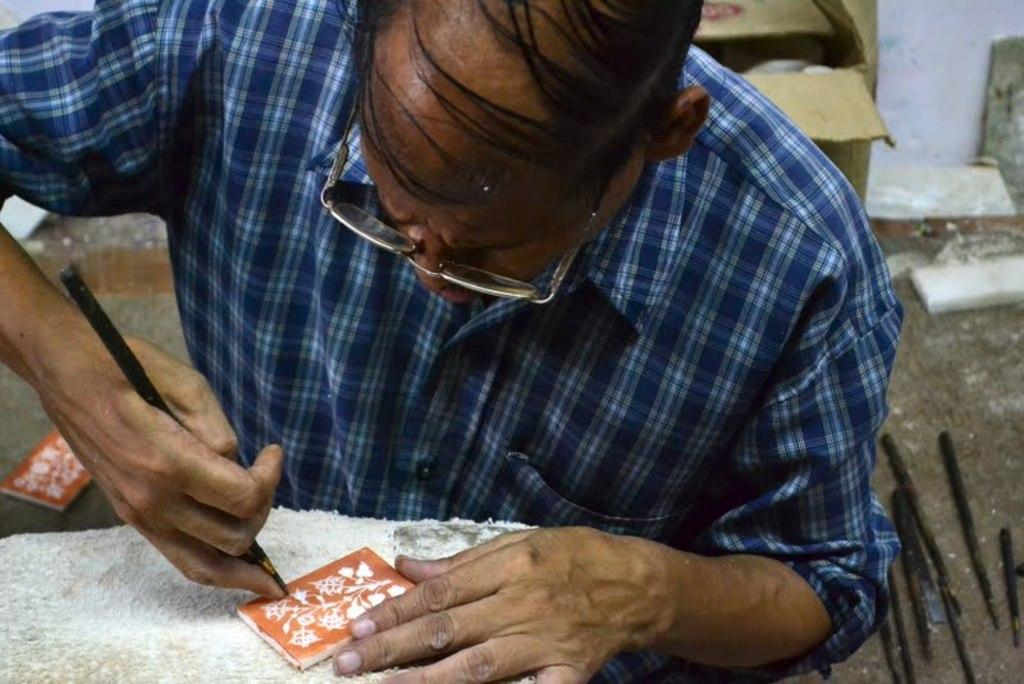What is the person in the image holding? There is a person holding an object in the image. What type of natural elements can be seen in the image? There are stones in the image. What type of material is present in the image? There is cloth in the image. What type of structure is visible in the image? There is a wall in the image. Can you describe any other objects in the image? There are other unspecified objects in the image. How does the nerve affect the deer in the image? There is no nerve or deer present in the image; it only features a person holding an object, stones, cloth, a wall, and other unspecified objects. 